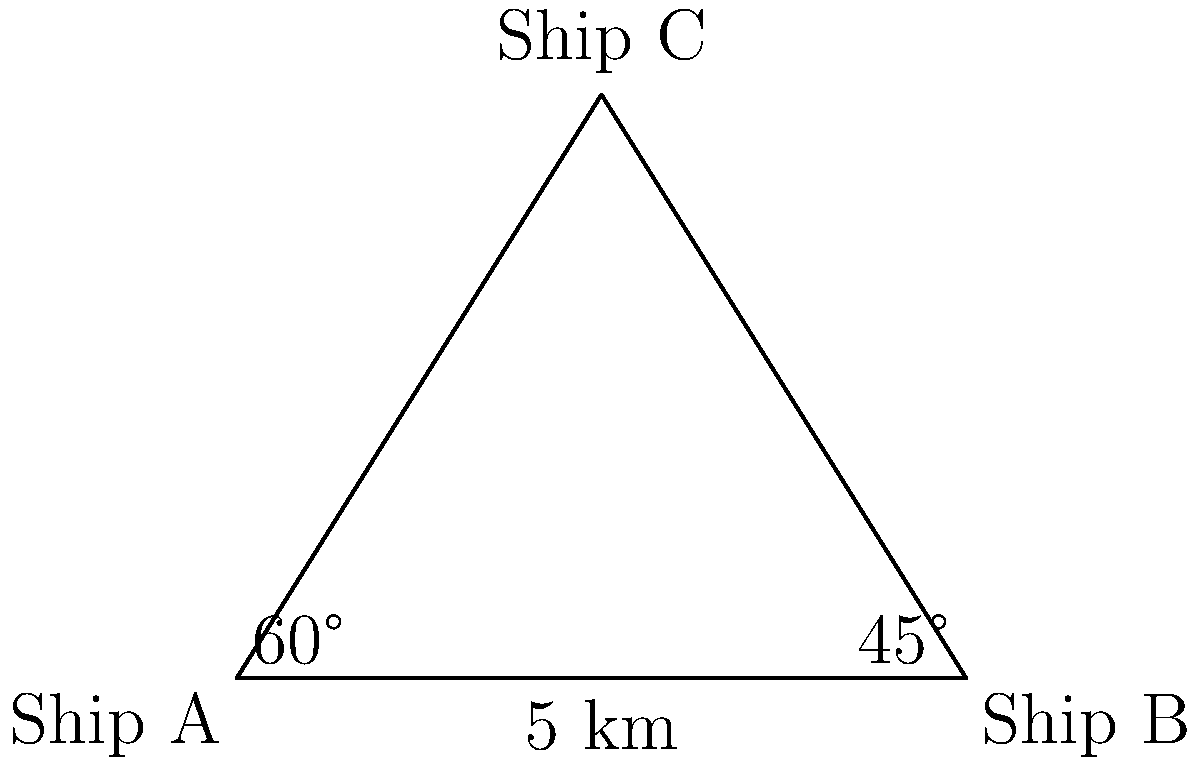Three ships are positioned at sea as shown in the diagram. Ship A and Ship B are 5 km apart. Ship C is detected by both ships A and B using radar. The radar from Ship A detects Ship C at a 60° angle from the line between A and B, while Ship B's radar detects Ship C at a 45° angle. Calculate the distance between Ship A and Ship C. Let's solve this step-by-step using trigonometry:

1) First, we can see that we have a triangle ABC.

2) We know the distance AB = 5 km, and we have two angles:
   Angle CAB = 60°
   Angle CBA = 45°

3) To find AC, we can use the sine law:

   $$\frac{AC}{\sin(CBA)} = \frac{AB}{\sin(ACB)}$$

4) We need to find angle ACB. In a triangle, the sum of all angles is 180°:
   
   ACB = 180° - 60° - 45° = 75°

5) Now we can plug these into the sine law:

   $$\frac{AC}{\sin(45°)} = \frac{5}{\sin(75°)}$$

6) Solve for AC:

   $$AC = \frac{5 \sin(45°)}{\sin(75°)}$$

7) Using a calculator (or knowing the exact values):
   
   $$AC = \frac{5 \cdot \frac{\sqrt{2}}{2}}{\frac{\sqrt{6}+\sqrt{2}}{4}} \approx 4.44 \text{ km}$$

Thus, the distance between Ship A and Ship C is approximately 4.44 km.
Answer: 4.44 km 